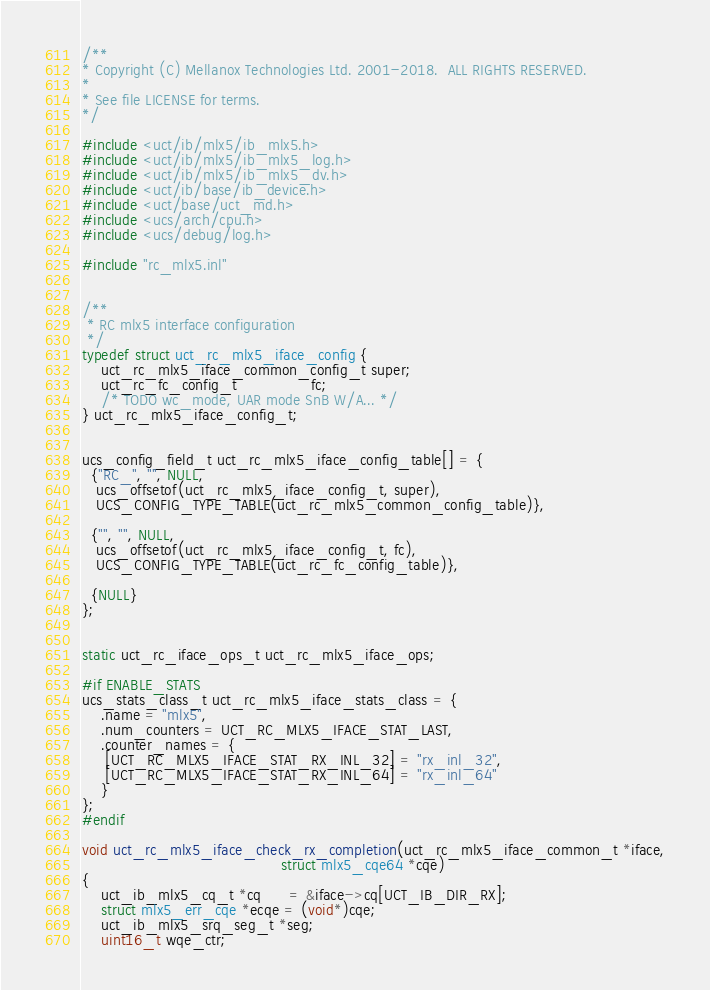Convert code to text. <code><loc_0><loc_0><loc_500><loc_500><_C_>/**
* Copyright (C) Mellanox Technologies Ltd. 2001-2018.  ALL RIGHTS RESERVED.
*
* See file LICENSE for terms.
*/

#include <uct/ib/mlx5/ib_mlx5.h>
#include <uct/ib/mlx5/ib_mlx5_log.h>
#include <uct/ib/mlx5/ib_mlx5_dv.h>
#include <uct/ib/base/ib_device.h>
#include <uct/base/uct_md.h>
#include <ucs/arch/cpu.h>
#include <ucs/debug/log.h>

#include "rc_mlx5.inl"


/**
 * RC mlx5 interface configuration
 */
typedef struct uct_rc_mlx5_iface_config {
    uct_rc_mlx5_iface_common_config_t super;
    uct_rc_fc_config_t                fc;
    /* TODO wc_mode, UAR mode SnB W/A... */
} uct_rc_mlx5_iface_config_t;


ucs_config_field_t uct_rc_mlx5_iface_config_table[] = {
  {"RC_", "", NULL,
   ucs_offsetof(uct_rc_mlx5_iface_config_t, super),
   UCS_CONFIG_TYPE_TABLE(uct_rc_mlx5_common_config_table)},

  {"", "", NULL,
   ucs_offsetof(uct_rc_mlx5_iface_config_t, fc),
   UCS_CONFIG_TYPE_TABLE(uct_rc_fc_config_table)},

  {NULL}
};


static uct_rc_iface_ops_t uct_rc_mlx5_iface_ops;

#if ENABLE_STATS
ucs_stats_class_t uct_rc_mlx5_iface_stats_class = {
    .name = "mlx5",
    .num_counters = UCT_RC_MLX5_IFACE_STAT_LAST,
    .counter_names = {
     [UCT_RC_MLX5_IFACE_STAT_RX_INL_32] = "rx_inl_32",
     [UCT_RC_MLX5_IFACE_STAT_RX_INL_64] = "rx_inl_64"
    }
};
#endif

void uct_rc_mlx5_iface_check_rx_completion(uct_rc_mlx5_iface_common_t *iface,
                                           struct mlx5_cqe64 *cqe)
{
    uct_ib_mlx5_cq_t *cq      = &iface->cq[UCT_IB_DIR_RX];
    struct mlx5_err_cqe *ecqe = (void*)cqe;
    uct_ib_mlx5_srq_seg_t *seg;
    uint16_t wqe_ctr;
</code> 